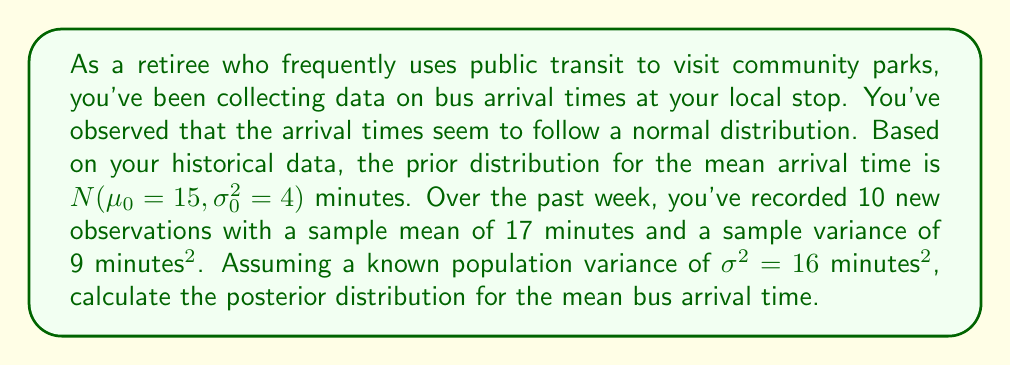Give your solution to this math problem. To solve this problem, we'll use Bayesian updating for a normal distribution with known variance. The steps are as follows:

1) Prior distribution: $\mu \sim N(\mu_0, \sigma_0^2)$
   $\mu_0 = 15$, $\sigma_0^2 = 4$

2) Likelihood: $X_i \sim N(\mu, \sigma^2)$
   $\bar{X} = 17$, $n = 10$, $\sigma^2 = 16$

3) The posterior distribution for $\mu$ is also normal with parameters:

   $$\mu_n = \frac{\frac{\mu_0}{\sigma_0^2} + \frac{n\bar{X}}{\sigma^2}}{\frac{1}{\sigma_0^2} + \frac{n}{\sigma^2}}$$

   $$\frac{1}{\sigma_n^2} = \frac{1}{\sigma_0^2} + \frac{n}{\sigma^2}$$

4) Let's calculate $\sigma_n^2$ first:

   $$\frac{1}{\sigma_n^2} = \frac{1}{4} + \frac{10}{16} = 0.25 + 0.625 = 0.875$$
   $$\sigma_n^2 = \frac{1}{0.875} = 1.143$$

5) Now, let's calculate $\mu_n$:

   $$\mu_n = \frac{\frac{15}{4} + \frac{10 \cdot 17}{16}}{\frac{1}{4} + \frac{10}{16}} = \frac{3.75 + 10.625}{0.875} = \frac{14.375}{0.875} = 16.429$$

Therefore, the posterior distribution is $N(16.429, 1.143)$.
Answer: The posterior distribution for the mean bus arrival time is $N(\mu_n = 16.429, \sigma_n^2 = 1.143)$ minutes. 